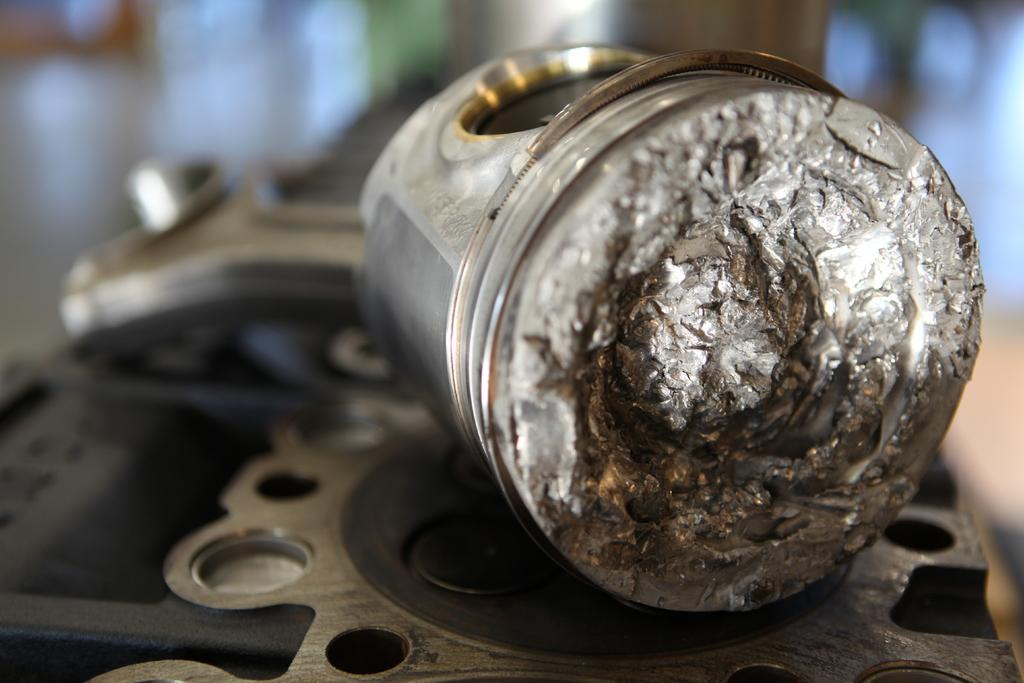What type of object is on the tool in the image? There is a metal object on a tool in the image. How does the force of light affect the addition of the metal object on the tool in the image? The image does not provide information about the force of light or any addition of the metal object on the tool, so it is not possible to answer that question. 